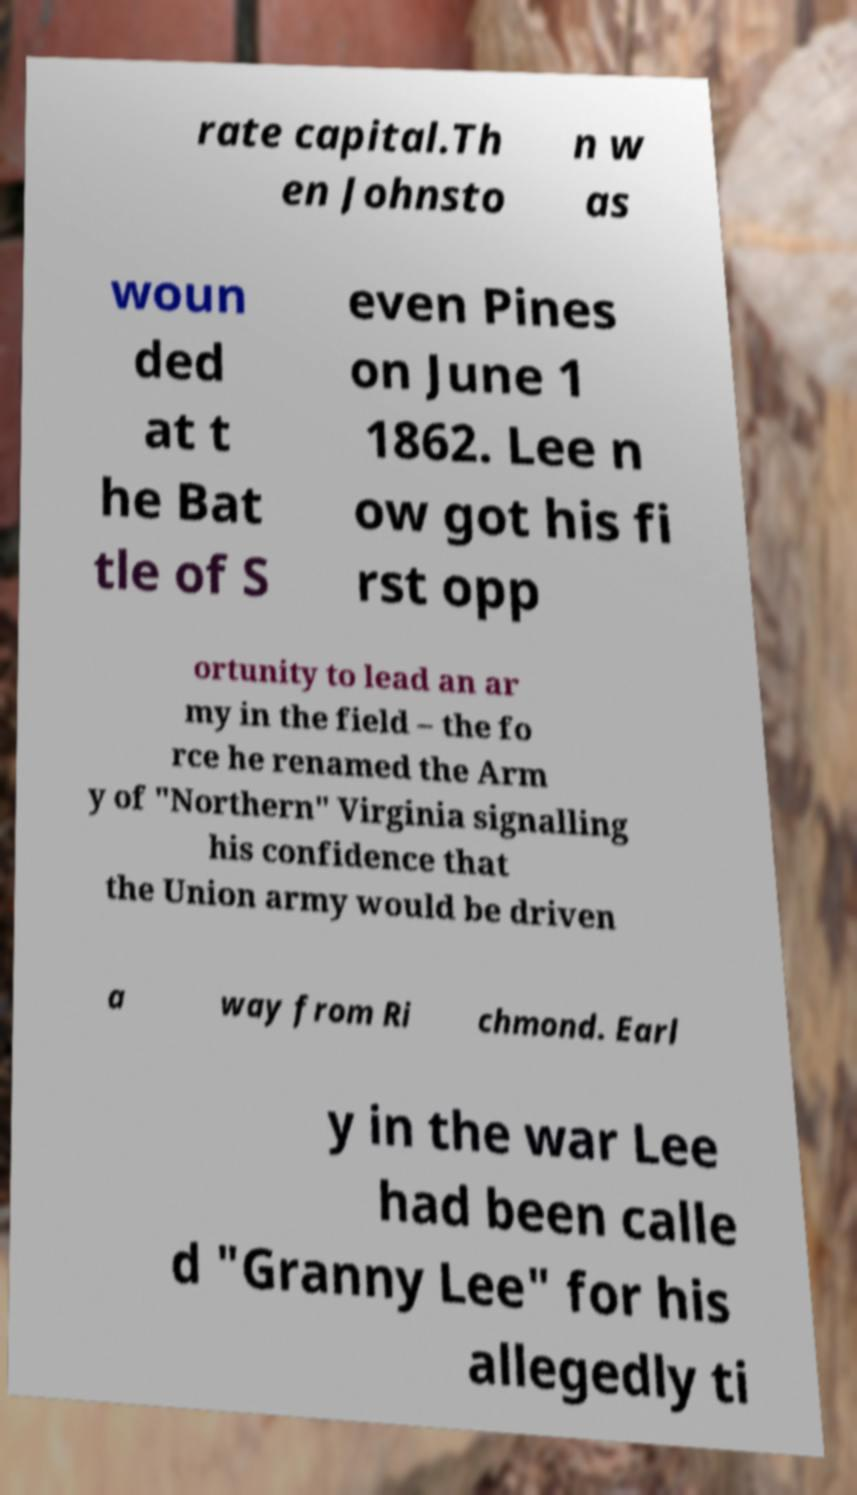Please identify and transcribe the text found in this image. rate capital.Th en Johnsto n w as woun ded at t he Bat tle of S even Pines on June 1 1862. Lee n ow got his fi rst opp ortunity to lead an ar my in the field – the fo rce he renamed the Arm y of "Northern" Virginia signalling his confidence that the Union army would be driven a way from Ri chmond. Earl y in the war Lee had been calle d "Granny Lee" for his allegedly ti 